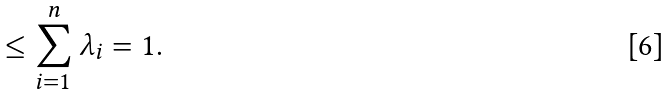<formula> <loc_0><loc_0><loc_500><loc_500>\leq \sum _ { i = 1 } ^ { n } \lambda _ { i } = 1 .</formula> 